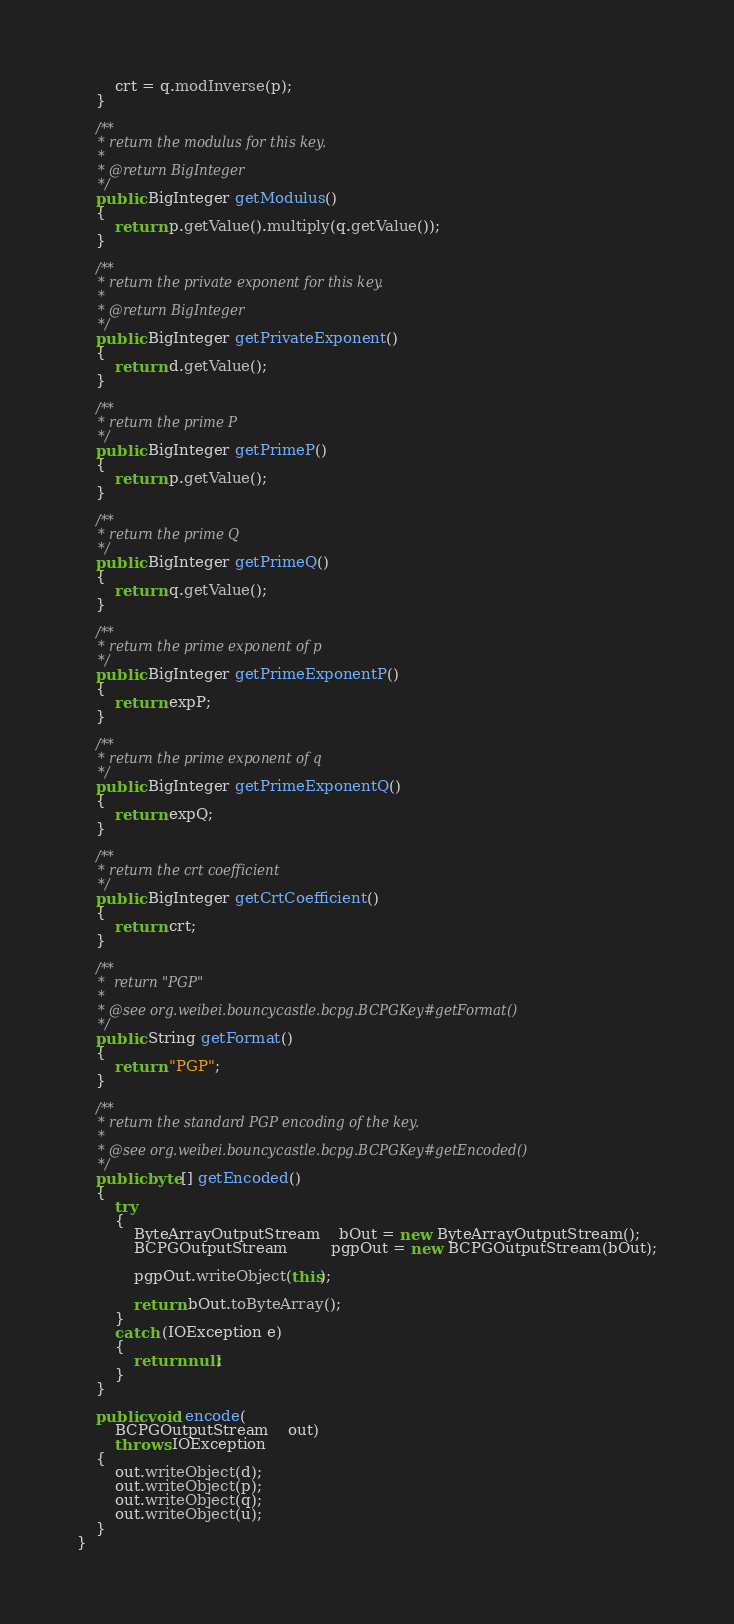Convert code to text. <code><loc_0><loc_0><loc_500><loc_500><_Java_>        crt = q.modInverse(p);
    }
    
    /**
     * return the modulus for this key.
     * 
     * @return BigInteger
     */
    public BigInteger getModulus()
    {
        return p.getValue().multiply(q.getValue());
    }
    
    /**
     * return the private exponent for this key.
     * 
     * @return BigInteger
     */
    public BigInteger getPrivateExponent()
    {
        return d.getValue();
    }
    
    /**
     * return the prime P
     */
    public BigInteger getPrimeP()
    {
        return p.getValue();
    }
    
    /**
     * return the prime Q
     */
    public BigInteger getPrimeQ()
    {
        return q.getValue();
    }
    
    /**
     * return the prime exponent of p
     */
    public BigInteger getPrimeExponentP()
    {
        return expP;
    }
    
    /**
     * return the prime exponent of q
     */
    public BigInteger getPrimeExponentQ()
    {
        return expQ;
    }
    
    /**
     * return the crt coefficient
     */
    public BigInteger getCrtCoefficient()
    {
        return crt;
    }
    
    /**
     *  return "PGP"
     * 
     * @see org.weibei.bouncycastle.bcpg.BCPGKey#getFormat()
     */
    public String getFormat() 
    {
        return "PGP";
    }

    /**
     * return the standard PGP encoding of the key.
     * 
     * @see org.weibei.bouncycastle.bcpg.BCPGKey#getEncoded()
     */
    public byte[] getEncoded() 
    {
        try
        { 
            ByteArrayOutputStream    bOut = new ByteArrayOutputStream();
            BCPGOutputStream         pgpOut = new BCPGOutputStream(bOut);
        
            pgpOut.writeObject(this);
        
            return bOut.toByteArray();
        }
        catch (IOException e)
        {
            return null;
        }
    }
    
    public void encode(
        BCPGOutputStream    out)
        throws IOException
    {
        out.writeObject(d);
        out.writeObject(p);
        out.writeObject(q);
        out.writeObject(u);
    }
}
</code> 